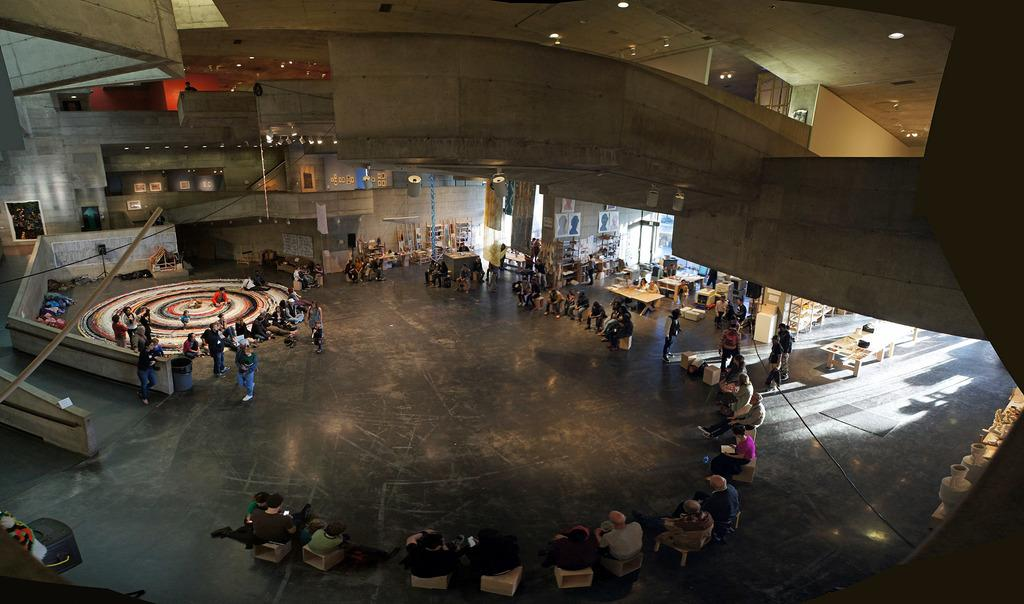Where was the image taken? The image was taken inside a building. What are the people in the image doing? Many people are sitting, and some are standing in the image. What type of furniture is present in the image? There are tables and chairs in the image. What can be seen at the top of the image? There are lights visible at the top of the image. What type of watch is the queen wearing in the image? There is no queen or watch present in the image. How much salt is on the tables in the image? There is no salt visible in the image; only tables, chairs, and people are present. 